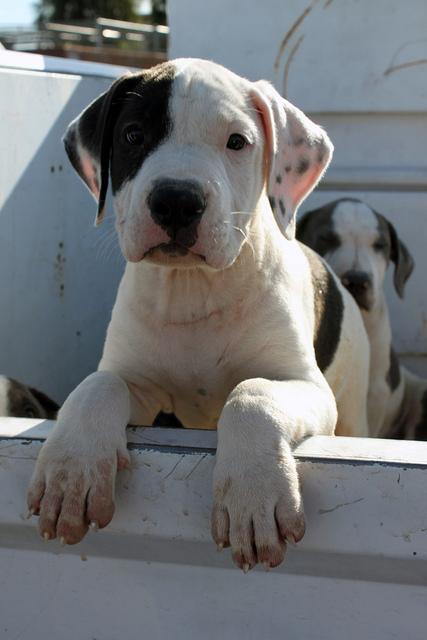Is this an old dog?
Short answer required. No. What feeling does the puppies face make you think of?
Write a very short answer. Sad. What type of animal is pictured?
Give a very brief answer. Dog. 